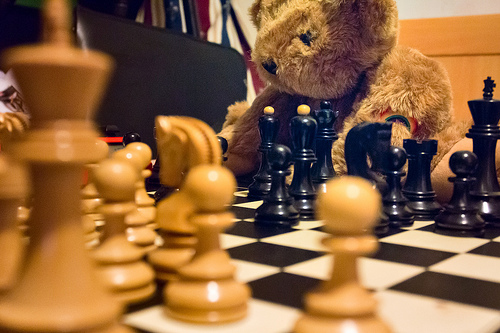<image>
Is there a stuffed bear on the chess piece? No. The stuffed bear is not positioned on the chess piece. They may be near each other, but the stuffed bear is not supported by or resting on top of the chess piece. Is the chess board next to the pawn? No. The chess board is not positioned next to the pawn. They are located in different areas of the scene. Is the piece in front of the piece? Yes. The piece is positioned in front of the piece, appearing closer to the camera viewpoint. Where is the teddy bear in relation to the chess piece? Is it in front of the chess piece? No. The teddy bear is not in front of the chess piece. The spatial positioning shows a different relationship between these objects. 